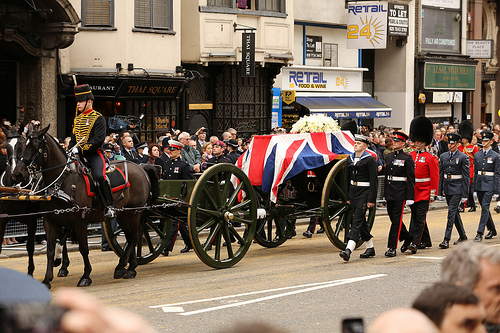What is happening in this image? In this image, a procession is taking place where a ceremonial wagon draped with a Union Jack flag is being pulled by a horse. Several men in uniform are walking alongside, and there are onlookers gathered behind barricades. The setting seems to be a formal event or parade, likely related to a significant celebration or memorial. Why do you think the wagon is draped with a flag? The flag draping over the wagon suggests it is a ceremonious or memorial event, possibly to honor a national figure or for a significant commemoration. The Union Jack signifies that it is likely a British event, and the formal uniforms and organized parade indicate the importance and solemnity of the occasion. Can you describe the atmosphere of the scene? The atmosphere of the scene appears to be solemn and respectful, with a sense of reverence. The crowd is gathered quietly behind the barricades, observing the procession. The participants are dressed in formal, ceremonial uniforms, and marching in unison, suggesting high protocol and organization. This indicates a formal event, likely a significant state ceremony or memorial service. If this procession were part of a movie, what story could it be telling? If this procession were part of a movie, it could be telling the story of a grand state funeral or a historic commemoration. The narrative might follow the lives of the individuals involved—perhaps the person honored by the ceremony had a significant impact on the country. Alternately, it could be an exploration of tradition and ceremony in a particular society, focusing on the roles and responsibilities of those participating in the procession. 